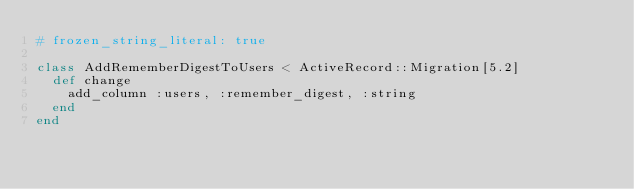<code> <loc_0><loc_0><loc_500><loc_500><_Ruby_># frozen_string_literal: true

class AddRememberDigestToUsers < ActiveRecord::Migration[5.2]
  def change
    add_column :users, :remember_digest, :string
  end
end
</code> 